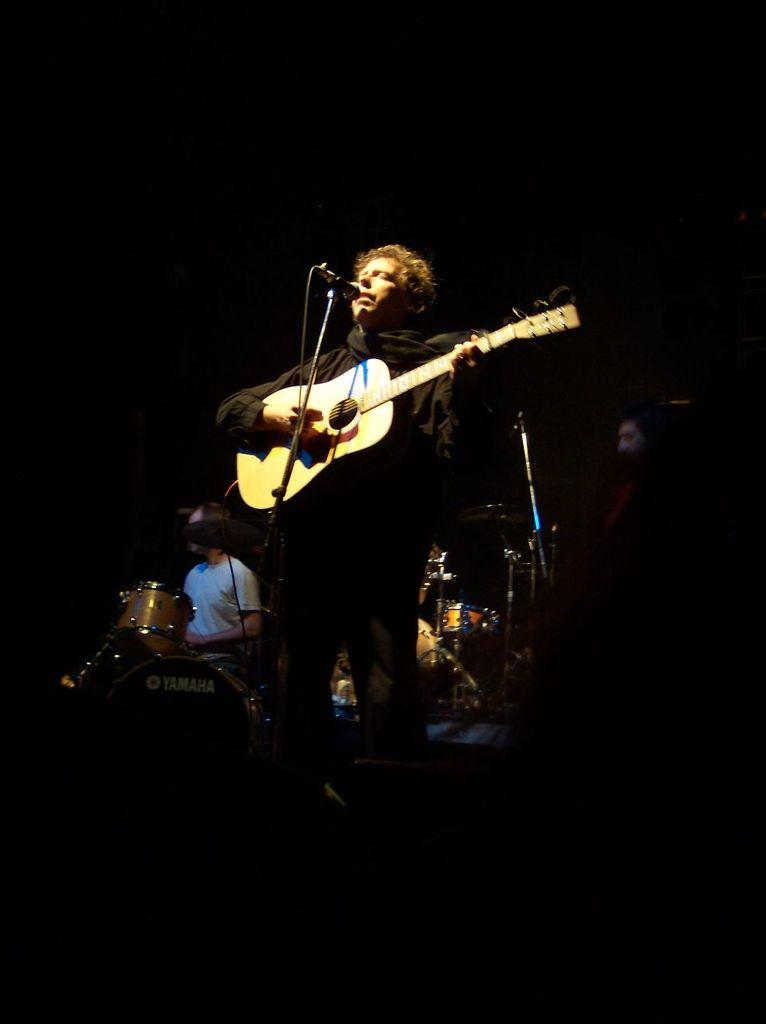What is the man in the image doing? The man is playing a guitar and singing. How is the man's voice being amplified in the image? The man is using a microphone. What is the other man in the image doing? The other man is seated and playing drums. What color is the recess in the image? There is no recess present in the image. What type of treatment is the man receiving for his guitar playing in the image? There is no indication in the image that the man is receiving any treatment for his guitar playing. 